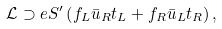<formula> <loc_0><loc_0><loc_500><loc_500>\mathcal { L } \supset e S ^ { \prime } \left ( f _ { L } \bar { u } _ { R } t _ { L } + f _ { R } \bar { u } _ { L } t _ { R } \right ) ,</formula> 